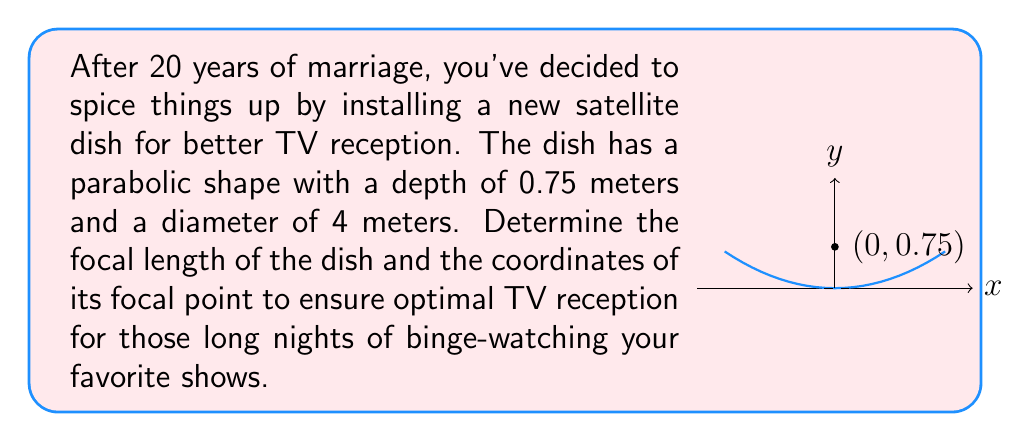Can you solve this math problem? Let's approach this step-by-step:

1) The general equation of a parabola with vertex at the origin and axis of symmetry along the y-axis is:

   $$y = \frac{1}{4p}x^2$$

   where $p$ is the focal length.

2) We know the depth (0.75 m) and diameter (4 m) of the dish. The depth corresponds to the y-coordinate of the endpoint, and half the diameter (2 m) corresponds to the x-coordinate.

3) Substituting these values into the equation:

   $$0.75 = \frac{1}{4p}(2^2)$$

4) Simplifying:

   $$0.75 = \frac{4}{4p}$$
   $$0.75 = \frac{1}{p}$$

5) Solving for $p$:

   $$p = \frac{1}{0.75} = \frac{4}{3} \approx 1.33$$

6) The focal length is 1.33 meters.

7) The focal point of a parabola is located on its axis of symmetry, $p$ units from the vertex. Since the vertex is at (0, 0), the focal point is at (0, 1.33).
Answer: Focal length: $\frac{4}{3}$ m; Focal point: (0, $\frac{4}{3}$) 